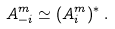<formula> <loc_0><loc_0><loc_500><loc_500>A _ { - i } ^ { m } \simeq ( A _ { i } ^ { m } ) ^ { * } \, .</formula> 